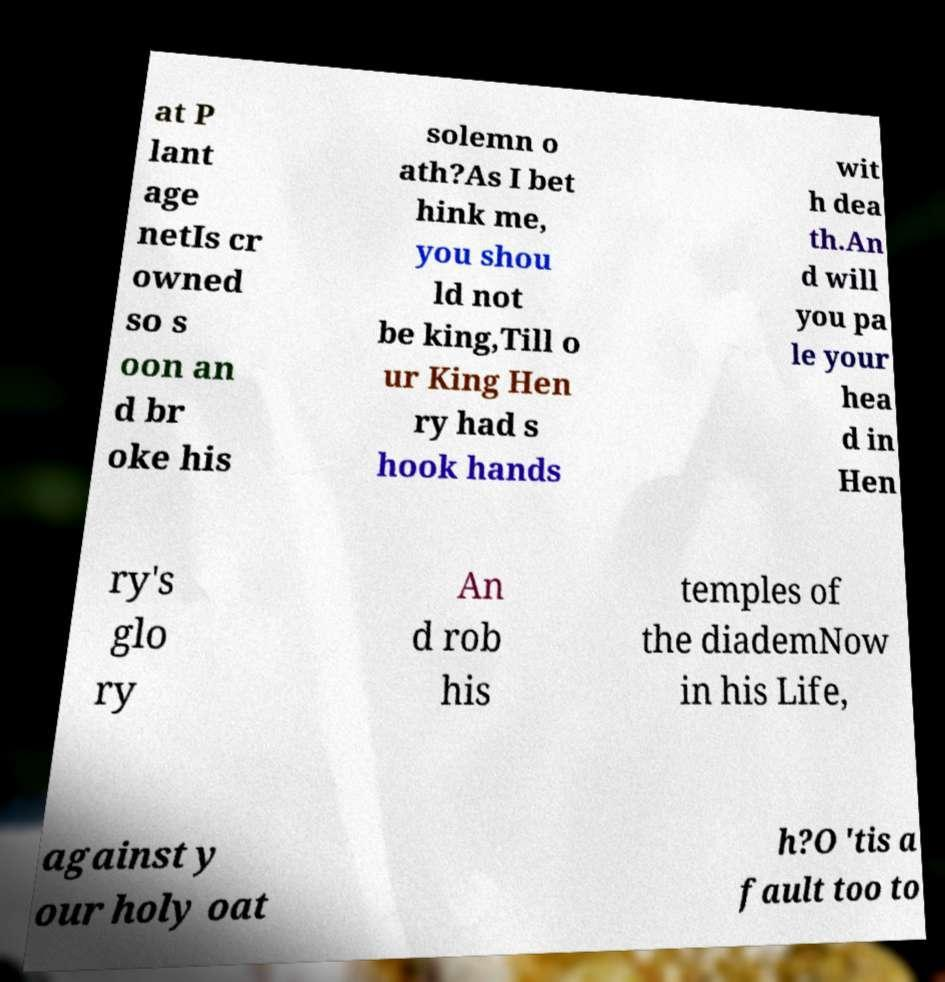What messages or text are displayed in this image? I need them in a readable, typed format. at P lant age netIs cr owned so s oon an d br oke his solemn o ath?As I bet hink me, you shou ld not be king,Till o ur King Hen ry had s hook hands wit h dea th.An d will you pa le your hea d in Hen ry's glo ry An d rob his temples of the diademNow in his Life, against y our holy oat h?O 'tis a fault too to 